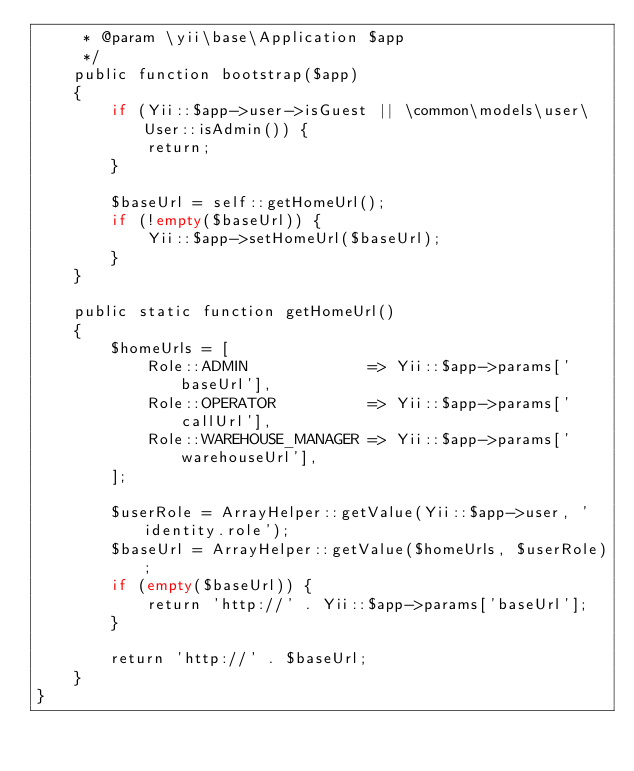Convert code to text. <code><loc_0><loc_0><loc_500><loc_500><_PHP_>     * @param \yii\base\Application $app
     */
    public function bootstrap($app)
    {
        if (Yii::$app->user->isGuest || \common\models\user\User::isAdmin()) {
            return;
        }

        $baseUrl = self::getHomeUrl();
        if (!empty($baseUrl)) {
            Yii::$app->setHomeUrl($baseUrl);
        }
    }

    public static function getHomeUrl()
    {
        $homeUrls = [
            Role::ADMIN             => Yii::$app->params['baseUrl'],
            Role::OPERATOR          => Yii::$app->params['callUrl'],
            Role::WAREHOUSE_MANAGER => Yii::$app->params['warehouseUrl'],
        ];

        $userRole = ArrayHelper::getValue(Yii::$app->user, 'identity.role');
        $baseUrl = ArrayHelper::getValue($homeUrls, $userRole);
        if (empty($baseUrl)) {
            return 'http://' . Yii::$app->params['baseUrl'];
        }

        return 'http://' . $baseUrl;
    }
}</code> 